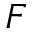<formula> <loc_0><loc_0><loc_500><loc_500>F</formula> 